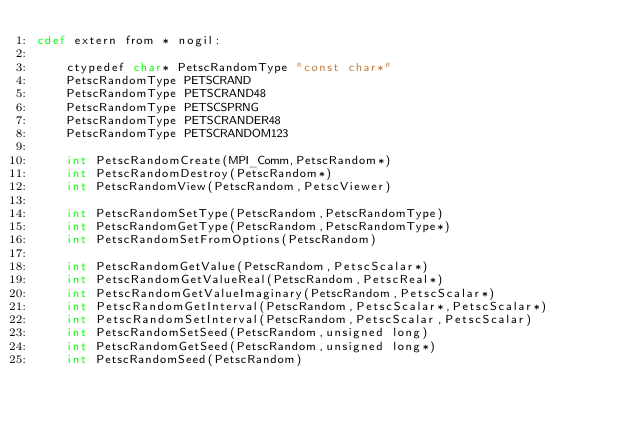Convert code to text. <code><loc_0><loc_0><loc_500><loc_500><_Cython_>cdef extern from * nogil:

    ctypedef char* PetscRandomType "const char*"
    PetscRandomType PETSCRAND
    PetscRandomType PETSCRAND48
    PetscRandomType PETSCSPRNG
    PetscRandomType PETSCRANDER48
    PetscRandomType PETSCRANDOM123

    int PetscRandomCreate(MPI_Comm,PetscRandom*)
    int PetscRandomDestroy(PetscRandom*)
    int PetscRandomView(PetscRandom,PetscViewer)

    int PetscRandomSetType(PetscRandom,PetscRandomType)
    int PetscRandomGetType(PetscRandom,PetscRandomType*)
    int PetscRandomSetFromOptions(PetscRandom)

    int PetscRandomGetValue(PetscRandom,PetscScalar*)
    int PetscRandomGetValueReal(PetscRandom,PetscReal*)
    int PetscRandomGetValueImaginary(PetscRandom,PetscScalar*)
    int PetscRandomGetInterval(PetscRandom,PetscScalar*,PetscScalar*)
    int PetscRandomSetInterval(PetscRandom,PetscScalar,PetscScalar)
    int PetscRandomSetSeed(PetscRandom,unsigned long)
    int PetscRandomGetSeed(PetscRandom,unsigned long*)
    int PetscRandomSeed(PetscRandom)
</code> 